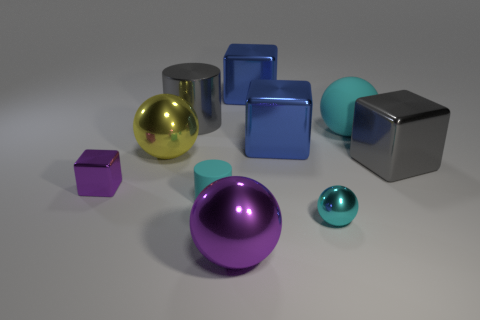Subtract 1 blocks. How many blocks are left? 3 Subtract all cylinders. How many objects are left? 8 Subtract 0 red spheres. How many objects are left? 10 Subtract all brown balls. Subtract all blue blocks. How many objects are left? 8 Add 7 big gray metallic blocks. How many big gray metallic blocks are left? 8 Add 5 small cyan rubber spheres. How many small cyan rubber spheres exist? 5 